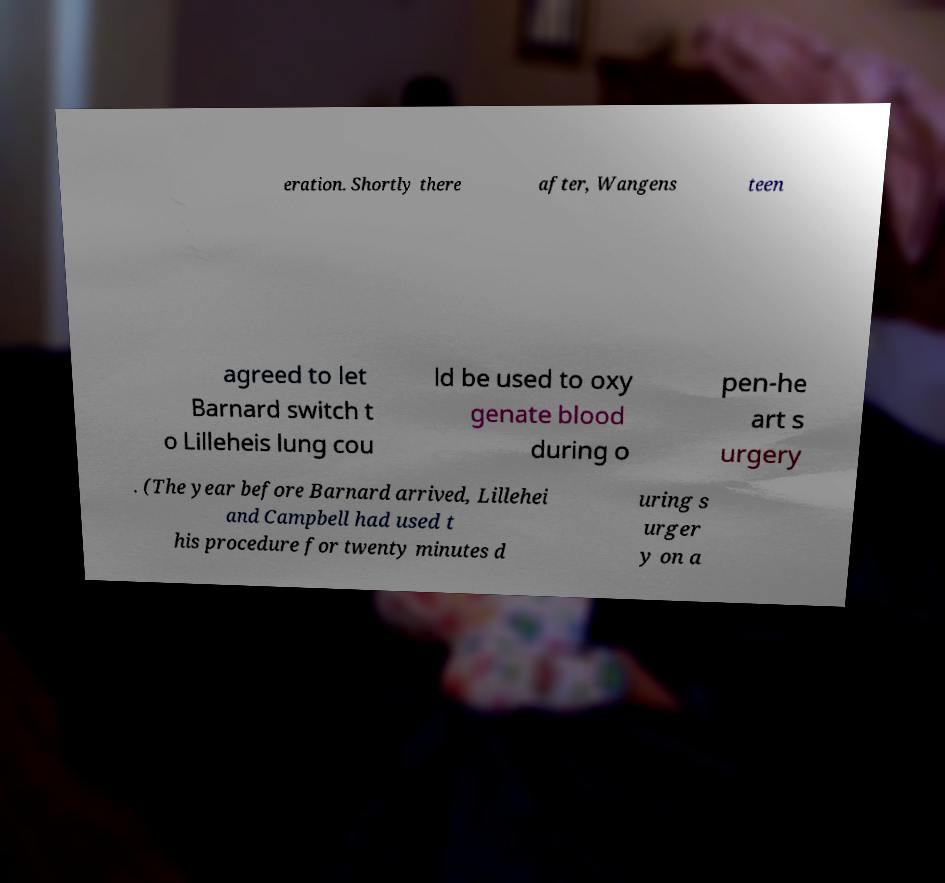Please identify and transcribe the text found in this image. eration. Shortly there after, Wangens teen agreed to let Barnard switch t o Lilleheis lung cou ld be used to oxy genate blood during o pen-he art s urgery . (The year before Barnard arrived, Lillehei and Campbell had used t his procedure for twenty minutes d uring s urger y on a 